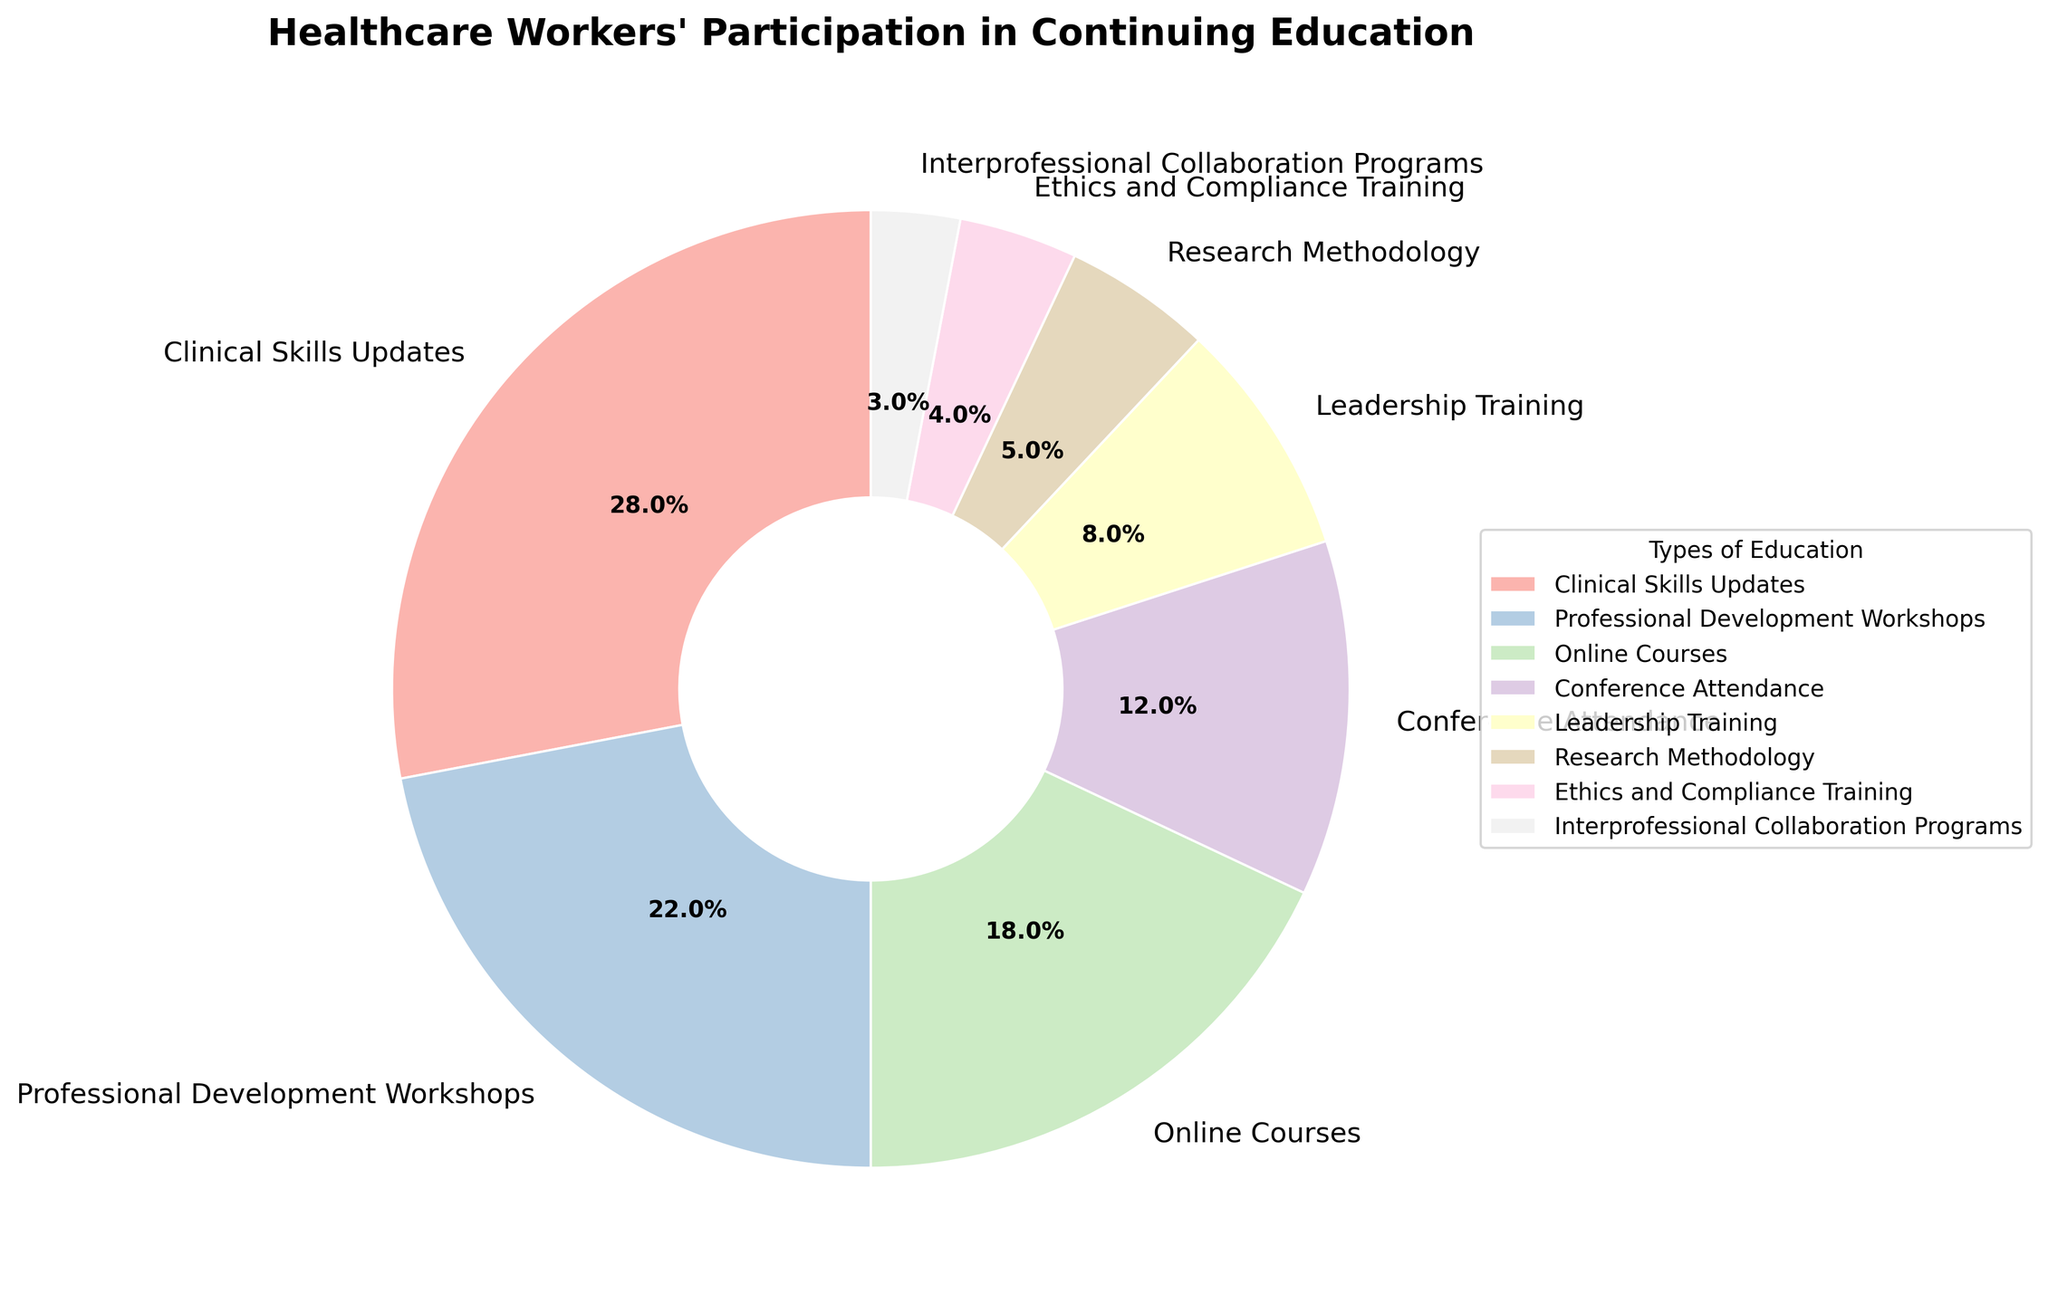What percentage of healthcare workers participate in Clinical Skills Updates and Professional Development Workshops combined? To find the combined percentage, add the percentage of healthcare workers participating in Clinical Skills Updates (28%) and those participating in Professional Development Workshops (22%). The sum is 28% + 22% = 50%.
Answer: 50% Which type of continuing education program has the least participation? The slice of the pie chart with the smallest wedge represents the program with the least participation. Ethic and Compliance Training has a 4% participation rate, and Interprofessional Collaboration Programs has an even smaller wedge at 3%.
Answer: Interprofessional Collaboration Programs How many times larger is the percentage for Clinical Skills Updates compared to Research Methodology? First, identify the percentage for Clinical Skills Updates (28%) and Research Methodology (5%). Calculate the ratio of the two percentages: 28% / 5% = 5.6. So, Clinical Skills Updates have a participation percentage 5.6 times larger than Research Methodology.
Answer: 5.6 What is the total percentage of healthcare workers participating in Conference Attendance, Leadership Training, Research Methodology, and Ethics and Compliance Training combined? Add the percentages for each category: Conference Attendance (12%), Leadership Training (8%), Research Methodology (5%), and Ethics and Compliance Training (4%). The combined percentage is 12% + 8% + 5% + 4% = 29%.
Answer: 29% Rank the types of continuing education programs from most participated to least participated. Examine each slice of the pie chart to rank the programs: 1) Clinical Skills Updates (28%), 2) Professional Development Workshops (22%), 3) Online Courses (18%), 4) Conference Attendance (12%), 5) Leadership Training (8%), 6) Research Methodology (5%), 7) Ethics and Compliance Training (4%), and 8) Interprofessional Collaboration Programs (3%).
Answer: Clinical Skills Updates, Professional Development Workshops, Online Courses, Conference Attendance, Leadership Training, Research Methodology, Ethics and Compliance Training, Interprofessional Collaboration Programs Is the percentage of participants in Leadership Training greater than those in Online Courses? Compare the percentages: Leadership Training (8%) and Online Courses (18%). Since 8% is less than 18%, Leadership Training has fewer participants than Online Courses.
Answer: No What is the difference in participation percentage between Clinical Skills Updates and Online Courses? Identify the percentages for Clinical Skills Updates (28%) and Online Courses (18%). Subtract the smaller percentage from the larger one: 28% - 18% = 10%.
Answer: 10% If you combine the participation percentages of Online Courses and Professional Development Workshops, how does it compare to Clinical Skills Updates? Calculate the combined percentage of Online Courses (18%) and Professional Development Workshops (22%): 18% + 22% = 40%. Clinical Skills Updates have 28%. Since 40% is greater than 28%, the combined percentage is greater than Clinical Skills Updates.
Answer: Greater What's the percentage of healthcare workers participating in programs focused on ethics-related training (Ethics and Compliance Training) compared to those participating in leadership-focused training (Leadership Training)? Compare the percentage for Ethics and Compliance Training (4%) to Leadership Training (8%). Since 8% is greater than 4%, more healthcare workers participate in Leadership Training.
Answer: Less 